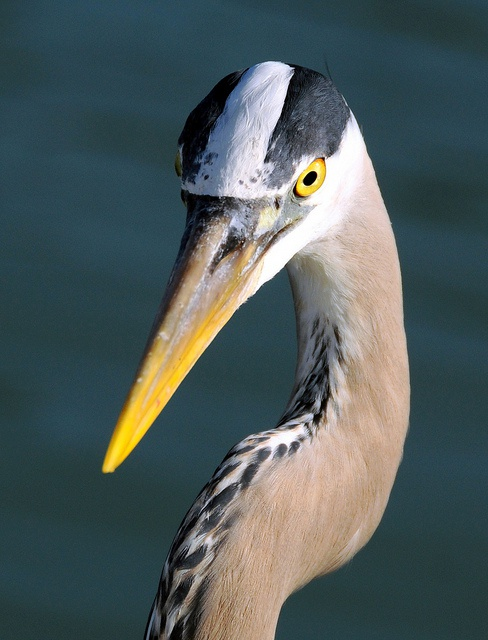Describe the objects in this image and their specific colors. I can see a bird in black, tan, darkgray, and lightgray tones in this image. 